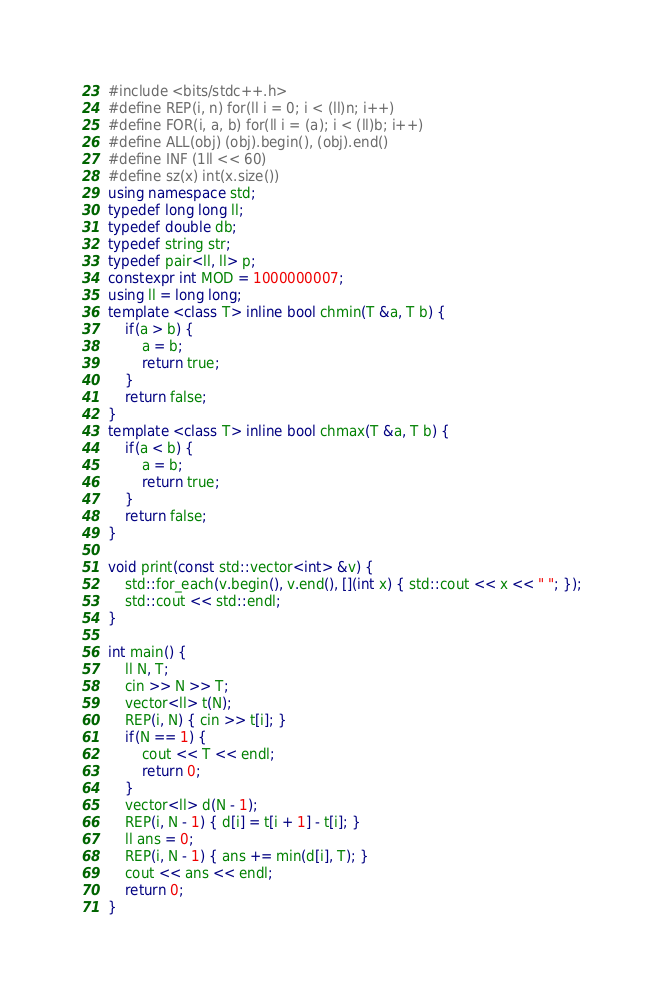Convert code to text. <code><loc_0><loc_0><loc_500><loc_500><_C++_>#include <bits/stdc++.h>
#define REP(i, n) for(ll i = 0; i < (ll)n; i++)
#define FOR(i, a, b) for(ll i = (a); i < (ll)b; i++)
#define ALL(obj) (obj).begin(), (obj).end()
#define INF (1ll << 60)
#define sz(x) int(x.size())
using namespace std;
typedef long long ll;
typedef double db;
typedef string str;
typedef pair<ll, ll> p;
constexpr int MOD = 1000000007;
using ll = long long;
template <class T> inline bool chmin(T &a, T b) {
    if(a > b) {
        a = b;
        return true;
    }
    return false;
}
template <class T> inline bool chmax(T &a, T b) {
    if(a < b) {
        a = b;
        return true;
    }
    return false;
}

void print(const std::vector<int> &v) {
    std::for_each(v.begin(), v.end(), [](int x) { std::cout << x << " "; });
    std::cout << std::endl;
}

int main() {
    ll N, T;
    cin >> N >> T;
    vector<ll> t(N);
    REP(i, N) { cin >> t[i]; }
    if(N == 1) {
        cout << T << endl;
        return 0;
    }
    vector<ll> d(N - 1);
    REP(i, N - 1) { d[i] = t[i + 1] - t[i]; }
    ll ans = 0;
    REP(i, N - 1) { ans += min(d[i], T); }
    cout << ans << endl;
    return 0;
}</code> 